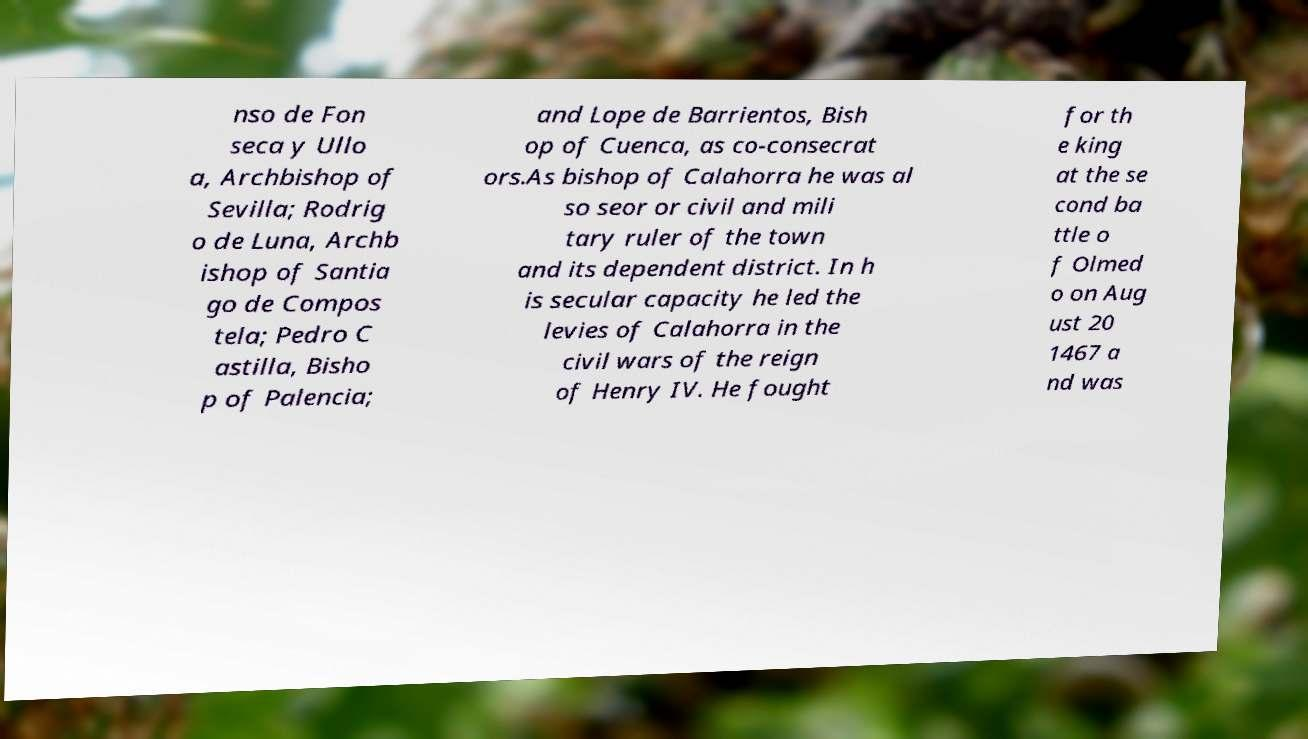There's text embedded in this image that I need extracted. Can you transcribe it verbatim? nso de Fon seca y Ullo a, Archbishop of Sevilla; Rodrig o de Luna, Archb ishop of Santia go de Compos tela; Pedro C astilla, Bisho p of Palencia; and Lope de Barrientos, Bish op of Cuenca, as co-consecrat ors.As bishop of Calahorra he was al so seor or civil and mili tary ruler of the town and its dependent district. In h is secular capacity he led the levies of Calahorra in the civil wars of the reign of Henry IV. He fought for th e king at the se cond ba ttle o f Olmed o on Aug ust 20 1467 a nd was 